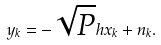Convert formula to latex. <formula><loc_0><loc_0><loc_500><loc_500>y _ { k } = - \sqrt { P } h x _ { k } + n _ { k } .</formula> 